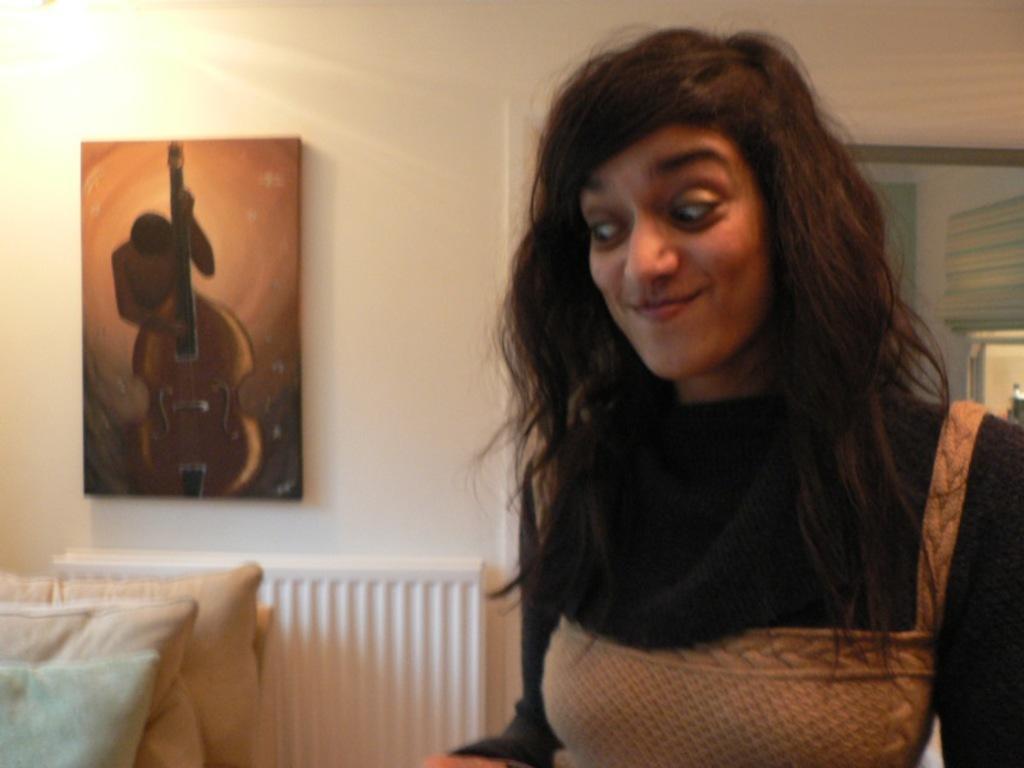Describe this image in one or two sentences. To the right side there is a lady with black and brown color dress. She is smiling and looking down. To the left side there are three pillars. And to the wall there is a frame. 